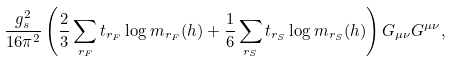Convert formula to latex. <formula><loc_0><loc_0><loc_500><loc_500>\frac { g _ { s } ^ { 2 } } { 1 6 \pi ^ { 2 } } \left ( \frac { 2 } { 3 } \sum _ { r _ { F } } t _ { r _ { F } } \log m _ { r _ { F } } ( h ) + \frac { 1 } { 6 } \sum _ { r _ { S } } t _ { r _ { S } } \log m _ { r _ { S } } ( h ) \right ) G _ { \mu \nu } G ^ { \mu \nu } ,</formula> 